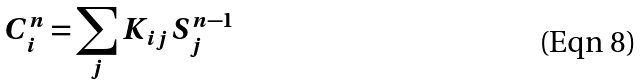Convert formula to latex. <formula><loc_0><loc_0><loc_500><loc_500>C _ { i } ^ { n } = \sum _ { j } K _ { i j } S ^ { n - 1 } _ { j }</formula> 